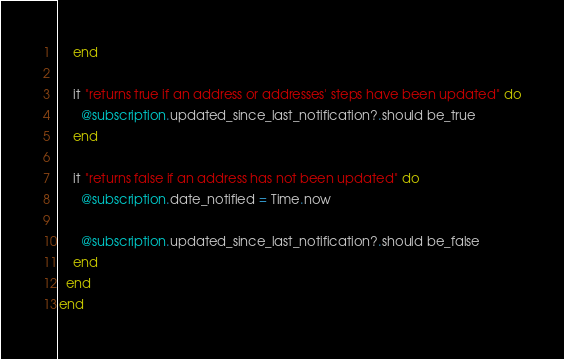Convert code to text. <code><loc_0><loc_0><loc_500><loc_500><_Ruby_>    end

    it "returns true if an address or addresses' steps have been updated" do
      @subscription.updated_since_last_notification?.should be_true
    end

    it "returns false if an address has not been updated" do
      @subscription.date_notified = Time.now

      @subscription.updated_since_last_notification?.should be_false
    end
  end
end
</code> 